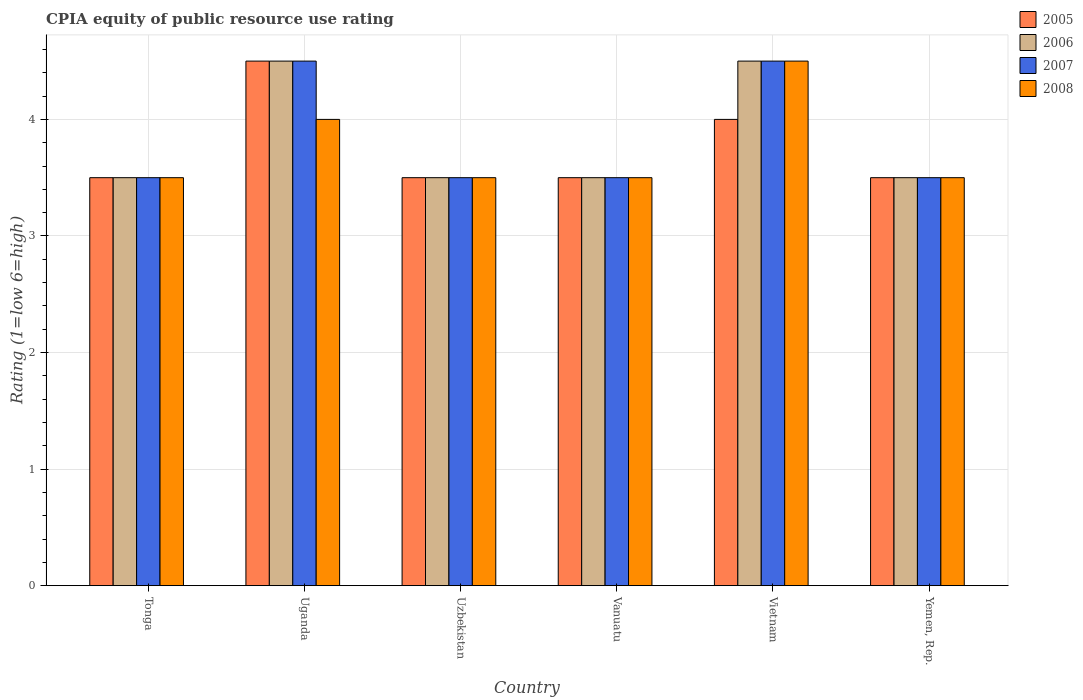Are the number of bars per tick equal to the number of legend labels?
Your answer should be very brief. Yes. Are the number of bars on each tick of the X-axis equal?
Make the answer very short. Yes. How many bars are there on the 4th tick from the right?
Make the answer very short. 4. What is the label of the 6th group of bars from the left?
Offer a very short reply. Yemen, Rep. What is the CPIA rating in 2008 in Uzbekistan?
Your answer should be compact. 3.5. Across all countries, what is the maximum CPIA rating in 2005?
Make the answer very short. 4.5. In which country was the CPIA rating in 2006 maximum?
Keep it short and to the point. Uganda. In which country was the CPIA rating in 2008 minimum?
Keep it short and to the point. Tonga. What is the average CPIA rating in 2007 per country?
Your answer should be very brief. 3.83. What is the difference between the CPIA rating of/in 2008 and CPIA rating of/in 2005 in Vanuatu?
Your response must be concise. 0. What is the ratio of the CPIA rating in 2008 in Uganda to that in Vanuatu?
Provide a succinct answer. 1.14. What is the difference between the highest and the second highest CPIA rating in 2005?
Ensure brevity in your answer.  -1. In how many countries, is the CPIA rating in 2005 greater than the average CPIA rating in 2005 taken over all countries?
Provide a short and direct response. 2. What does the 4th bar from the right in Uzbekistan represents?
Offer a terse response. 2005. Where does the legend appear in the graph?
Keep it short and to the point. Top right. What is the title of the graph?
Your answer should be compact. CPIA equity of public resource use rating. What is the label or title of the X-axis?
Provide a succinct answer. Country. What is the label or title of the Y-axis?
Offer a very short reply. Rating (1=low 6=high). What is the Rating (1=low 6=high) of 2005 in Tonga?
Your response must be concise. 3.5. What is the Rating (1=low 6=high) of 2006 in Tonga?
Provide a succinct answer. 3.5. What is the Rating (1=low 6=high) of 2007 in Tonga?
Offer a terse response. 3.5. What is the Rating (1=low 6=high) in 2008 in Tonga?
Provide a succinct answer. 3.5. What is the Rating (1=low 6=high) of 2005 in Uganda?
Ensure brevity in your answer.  4.5. What is the Rating (1=low 6=high) in 2006 in Uganda?
Your answer should be compact. 4.5. What is the Rating (1=low 6=high) in 2007 in Uganda?
Ensure brevity in your answer.  4.5. What is the Rating (1=low 6=high) in 2008 in Uganda?
Your answer should be compact. 4. What is the Rating (1=low 6=high) in 2006 in Uzbekistan?
Your response must be concise. 3.5. What is the Rating (1=low 6=high) of 2007 in Uzbekistan?
Offer a terse response. 3.5. What is the Rating (1=low 6=high) of 2008 in Uzbekistan?
Offer a terse response. 3.5. What is the Rating (1=low 6=high) of 2007 in Vanuatu?
Ensure brevity in your answer.  3.5. What is the Rating (1=low 6=high) in 2005 in Vietnam?
Make the answer very short. 4. What is the Rating (1=low 6=high) of 2006 in Vietnam?
Make the answer very short. 4.5. What is the Rating (1=low 6=high) in 2007 in Vietnam?
Provide a succinct answer. 4.5. What is the Rating (1=low 6=high) of 2007 in Yemen, Rep.?
Make the answer very short. 3.5. Across all countries, what is the maximum Rating (1=low 6=high) of 2005?
Ensure brevity in your answer.  4.5. Across all countries, what is the maximum Rating (1=low 6=high) of 2007?
Give a very brief answer. 4.5. Across all countries, what is the minimum Rating (1=low 6=high) of 2005?
Provide a short and direct response. 3.5. Across all countries, what is the minimum Rating (1=low 6=high) of 2006?
Offer a very short reply. 3.5. What is the total Rating (1=low 6=high) in 2005 in the graph?
Your response must be concise. 22.5. What is the total Rating (1=low 6=high) of 2007 in the graph?
Your answer should be compact. 23. What is the total Rating (1=low 6=high) of 2008 in the graph?
Ensure brevity in your answer.  22.5. What is the difference between the Rating (1=low 6=high) in 2006 in Tonga and that in Uganda?
Provide a short and direct response. -1. What is the difference between the Rating (1=low 6=high) of 2006 in Tonga and that in Uzbekistan?
Offer a terse response. 0. What is the difference between the Rating (1=low 6=high) of 2005 in Tonga and that in Vanuatu?
Offer a terse response. 0. What is the difference between the Rating (1=low 6=high) of 2006 in Tonga and that in Vanuatu?
Offer a very short reply. 0. What is the difference between the Rating (1=low 6=high) in 2007 in Tonga and that in Vanuatu?
Keep it short and to the point. 0. What is the difference between the Rating (1=low 6=high) of 2008 in Tonga and that in Vanuatu?
Provide a succinct answer. 0. What is the difference between the Rating (1=low 6=high) in 2005 in Tonga and that in Vietnam?
Your response must be concise. -0.5. What is the difference between the Rating (1=low 6=high) of 2008 in Tonga and that in Vietnam?
Provide a short and direct response. -1. What is the difference between the Rating (1=low 6=high) in 2005 in Tonga and that in Yemen, Rep.?
Give a very brief answer. 0. What is the difference between the Rating (1=low 6=high) of 2006 in Tonga and that in Yemen, Rep.?
Your answer should be compact. 0. What is the difference between the Rating (1=low 6=high) in 2005 in Uganda and that in Uzbekistan?
Provide a short and direct response. 1. What is the difference between the Rating (1=low 6=high) of 2006 in Uganda and that in Uzbekistan?
Provide a succinct answer. 1. What is the difference between the Rating (1=low 6=high) in 2007 in Uganda and that in Vanuatu?
Your answer should be very brief. 1. What is the difference between the Rating (1=low 6=high) in 2005 in Uganda and that in Vietnam?
Offer a very short reply. 0.5. What is the difference between the Rating (1=low 6=high) in 2006 in Uganda and that in Vietnam?
Your response must be concise. 0. What is the difference between the Rating (1=low 6=high) in 2007 in Uganda and that in Vietnam?
Provide a succinct answer. 0. What is the difference between the Rating (1=low 6=high) in 2008 in Uganda and that in Vietnam?
Offer a very short reply. -0.5. What is the difference between the Rating (1=low 6=high) in 2006 in Uganda and that in Yemen, Rep.?
Keep it short and to the point. 1. What is the difference between the Rating (1=low 6=high) of 2006 in Uzbekistan and that in Vanuatu?
Your answer should be very brief. 0. What is the difference between the Rating (1=low 6=high) of 2007 in Uzbekistan and that in Vanuatu?
Give a very brief answer. 0. What is the difference between the Rating (1=low 6=high) of 2005 in Uzbekistan and that in Vietnam?
Ensure brevity in your answer.  -0.5. What is the difference between the Rating (1=low 6=high) of 2007 in Uzbekistan and that in Vietnam?
Your answer should be very brief. -1. What is the difference between the Rating (1=low 6=high) of 2008 in Uzbekistan and that in Yemen, Rep.?
Give a very brief answer. 0. What is the difference between the Rating (1=low 6=high) of 2005 in Vanuatu and that in Vietnam?
Offer a very short reply. -0.5. What is the difference between the Rating (1=low 6=high) in 2007 in Vanuatu and that in Vietnam?
Your answer should be very brief. -1. What is the difference between the Rating (1=low 6=high) of 2008 in Vanuatu and that in Vietnam?
Make the answer very short. -1. What is the difference between the Rating (1=low 6=high) of 2005 in Vanuatu and that in Yemen, Rep.?
Make the answer very short. 0. What is the difference between the Rating (1=low 6=high) in 2007 in Vanuatu and that in Yemen, Rep.?
Give a very brief answer. 0. What is the difference between the Rating (1=low 6=high) in 2008 in Vanuatu and that in Yemen, Rep.?
Your answer should be compact. 0. What is the difference between the Rating (1=low 6=high) in 2005 in Vietnam and that in Yemen, Rep.?
Offer a terse response. 0.5. What is the difference between the Rating (1=low 6=high) of 2006 in Vietnam and that in Yemen, Rep.?
Provide a short and direct response. 1. What is the difference between the Rating (1=low 6=high) in 2005 in Tonga and the Rating (1=low 6=high) in 2007 in Uganda?
Your response must be concise. -1. What is the difference between the Rating (1=low 6=high) of 2006 in Tonga and the Rating (1=low 6=high) of 2007 in Uganda?
Ensure brevity in your answer.  -1. What is the difference between the Rating (1=low 6=high) in 2007 in Tonga and the Rating (1=low 6=high) in 2008 in Uganda?
Offer a terse response. -0.5. What is the difference between the Rating (1=low 6=high) of 2005 in Tonga and the Rating (1=low 6=high) of 2006 in Uzbekistan?
Offer a very short reply. 0. What is the difference between the Rating (1=low 6=high) in 2005 in Tonga and the Rating (1=low 6=high) in 2008 in Uzbekistan?
Your answer should be compact. 0. What is the difference between the Rating (1=low 6=high) in 2006 in Tonga and the Rating (1=low 6=high) in 2007 in Uzbekistan?
Ensure brevity in your answer.  0. What is the difference between the Rating (1=low 6=high) in 2006 in Tonga and the Rating (1=low 6=high) in 2008 in Uzbekistan?
Offer a very short reply. 0. What is the difference between the Rating (1=low 6=high) of 2005 in Tonga and the Rating (1=low 6=high) of 2007 in Vanuatu?
Offer a terse response. 0. What is the difference between the Rating (1=low 6=high) of 2005 in Tonga and the Rating (1=low 6=high) of 2008 in Vanuatu?
Make the answer very short. 0. What is the difference between the Rating (1=low 6=high) in 2006 in Tonga and the Rating (1=low 6=high) in 2007 in Vanuatu?
Your response must be concise. 0. What is the difference between the Rating (1=low 6=high) in 2007 in Tonga and the Rating (1=low 6=high) in 2008 in Vanuatu?
Give a very brief answer. 0. What is the difference between the Rating (1=low 6=high) of 2005 in Tonga and the Rating (1=low 6=high) of 2006 in Vietnam?
Provide a short and direct response. -1. What is the difference between the Rating (1=low 6=high) in 2005 in Tonga and the Rating (1=low 6=high) in 2008 in Vietnam?
Make the answer very short. -1. What is the difference between the Rating (1=low 6=high) in 2006 in Tonga and the Rating (1=low 6=high) in 2008 in Vietnam?
Offer a terse response. -1. What is the difference between the Rating (1=low 6=high) of 2007 in Tonga and the Rating (1=low 6=high) of 2008 in Vietnam?
Your answer should be very brief. -1. What is the difference between the Rating (1=low 6=high) in 2005 in Tonga and the Rating (1=low 6=high) in 2006 in Yemen, Rep.?
Provide a short and direct response. 0. What is the difference between the Rating (1=low 6=high) in 2005 in Tonga and the Rating (1=low 6=high) in 2007 in Yemen, Rep.?
Offer a very short reply. 0. What is the difference between the Rating (1=low 6=high) of 2005 in Tonga and the Rating (1=low 6=high) of 2008 in Yemen, Rep.?
Offer a very short reply. 0. What is the difference between the Rating (1=low 6=high) of 2006 in Tonga and the Rating (1=low 6=high) of 2008 in Yemen, Rep.?
Your response must be concise. 0. What is the difference between the Rating (1=low 6=high) in 2005 in Uganda and the Rating (1=low 6=high) in 2007 in Uzbekistan?
Make the answer very short. 1. What is the difference between the Rating (1=low 6=high) in 2005 in Uganda and the Rating (1=low 6=high) in 2008 in Uzbekistan?
Your answer should be compact. 1. What is the difference between the Rating (1=low 6=high) of 2006 in Uganda and the Rating (1=low 6=high) of 2008 in Uzbekistan?
Offer a terse response. 1. What is the difference between the Rating (1=low 6=high) of 2005 in Uganda and the Rating (1=low 6=high) of 2006 in Vanuatu?
Make the answer very short. 1. What is the difference between the Rating (1=low 6=high) of 2006 in Uganda and the Rating (1=low 6=high) of 2008 in Vanuatu?
Your response must be concise. 1. What is the difference between the Rating (1=low 6=high) of 2007 in Uganda and the Rating (1=low 6=high) of 2008 in Vanuatu?
Provide a short and direct response. 1. What is the difference between the Rating (1=low 6=high) of 2005 in Uganda and the Rating (1=low 6=high) of 2006 in Vietnam?
Give a very brief answer. 0. What is the difference between the Rating (1=low 6=high) of 2005 in Uganda and the Rating (1=low 6=high) of 2007 in Vietnam?
Your answer should be compact. 0. What is the difference between the Rating (1=low 6=high) in 2005 in Uganda and the Rating (1=low 6=high) in 2008 in Vietnam?
Offer a very short reply. 0. What is the difference between the Rating (1=low 6=high) in 2007 in Uganda and the Rating (1=low 6=high) in 2008 in Vietnam?
Your answer should be very brief. 0. What is the difference between the Rating (1=low 6=high) of 2005 in Uganda and the Rating (1=low 6=high) of 2006 in Yemen, Rep.?
Offer a very short reply. 1. What is the difference between the Rating (1=low 6=high) in 2005 in Uganda and the Rating (1=low 6=high) in 2008 in Yemen, Rep.?
Keep it short and to the point. 1. What is the difference between the Rating (1=low 6=high) in 2007 in Uganda and the Rating (1=low 6=high) in 2008 in Yemen, Rep.?
Keep it short and to the point. 1. What is the difference between the Rating (1=low 6=high) in 2005 in Uzbekistan and the Rating (1=low 6=high) in 2008 in Vanuatu?
Your answer should be compact. 0. What is the difference between the Rating (1=low 6=high) of 2006 in Uzbekistan and the Rating (1=low 6=high) of 2007 in Vietnam?
Make the answer very short. -1. What is the difference between the Rating (1=low 6=high) in 2007 in Uzbekistan and the Rating (1=low 6=high) in 2008 in Vietnam?
Ensure brevity in your answer.  -1. What is the difference between the Rating (1=low 6=high) in 2005 in Uzbekistan and the Rating (1=low 6=high) in 2006 in Yemen, Rep.?
Provide a succinct answer. 0. What is the difference between the Rating (1=low 6=high) of 2005 in Uzbekistan and the Rating (1=low 6=high) of 2007 in Yemen, Rep.?
Provide a succinct answer. 0. What is the difference between the Rating (1=low 6=high) of 2006 in Uzbekistan and the Rating (1=low 6=high) of 2007 in Yemen, Rep.?
Keep it short and to the point. 0. What is the difference between the Rating (1=low 6=high) in 2005 in Vanuatu and the Rating (1=low 6=high) in 2007 in Vietnam?
Your answer should be very brief. -1. What is the difference between the Rating (1=low 6=high) of 2005 in Vanuatu and the Rating (1=low 6=high) of 2008 in Vietnam?
Provide a short and direct response. -1. What is the difference between the Rating (1=low 6=high) in 2007 in Vanuatu and the Rating (1=low 6=high) in 2008 in Vietnam?
Ensure brevity in your answer.  -1. What is the difference between the Rating (1=low 6=high) in 2006 in Vanuatu and the Rating (1=low 6=high) in 2008 in Yemen, Rep.?
Make the answer very short. 0. What is the difference between the Rating (1=low 6=high) in 2005 in Vietnam and the Rating (1=low 6=high) in 2007 in Yemen, Rep.?
Keep it short and to the point. 0.5. What is the difference between the Rating (1=low 6=high) in 2006 in Vietnam and the Rating (1=low 6=high) in 2007 in Yemen, Rep.?
Offer a terse response. 1. What is the average Rating (1=low 6=high) of 2005 per country?
Give a very brief answer. 3.75. What is the average Rating (1=low 6=high) in 2006 per country?
Ensure brevity in your answer.  3.83. What is the average Rating (1=low 6=high) in 2007 per country?
Provide a succinct answer. 3.83. What is the average Rating (1=low 6=high) of 2008 per country?
Your answer should be very brief. 3.75. What is the difference between the Rating (1=low 6=high) of 2005 and Rating (1=low 6=high) of 2006 in Tonga?
Provide a short and direct response. 0. What is the difference between the Rating (1=low 6=high) in 2005 and Rating (1=low 6=high) in 2008 in Tonga?
Your answer should be very brief. 0. What is the difference between the Rating (1=low 6=high) in 2006 and Rating (1=low 6=high) in 2007 in Tonga?
Keep it short and to the point. 0. What is the difference between the Rating (1=low 6=high) of 2005 and Rating (1=low 6=high) of 2007 in Uganda?
Your response must be concise. 0. What is the difference between the Rating (1=low 6=high) of 2006 and Rating (1=low 6=high) of 2008 in Uganda?
Offer a terse response. 0.5. What is the difference between the Rating (1=low 6=high) in 2005 and Rating (1=low 6=high) in 2008 in Uzbekistan?
Offer a very short reply. 0. What is the difference between the Rating (1=low 6=high) in 2006 and Rating (1=low 6=high) in 2008 in Uzbekistan?
Ensure brevity in your answer.  0. What is the difference between the Rating (1=low 6=high) in 2007 and Rating (1=low 6=high) in 2008 in Uzbekistan?
Give a very brief answer. 0. What is the difference between the Rating (1=low 6=high) in 2005 and Rating (1=low 6=high) in 2006 in Vanuatu?
Offer a terse response. 0. What is the difference between the Rating (1=low 6=high) of 2006 and Rating (1=low 6=high) of 2007 in Vanuatu?
Offer a terse response. 0. What is the difference between the Rating (1=low 6=high) of 2006 and Rating (1=low 6=high) of 2008 in Vanuatu?
Provide a succinct answer. 0. What is the difference between the Rating (1=low 6=high) of 2005 and Rating (1=low 6=high) of 2006 in Vietnam?
Provide a short and direct response. -0.5. What is the difference between the Rating (1=low 6=high) of 2005 and Rating (1=low 6=high) of 2007 in Vietnam?
Provide a short and direct response. -0.5. What is the difference between the Rating (1=low 6=high) in 2006 and Rating (1=low 6=high) in 2007 in Vietnam?
Give a very brief answer. 0. What is the difference between the Rating (1=low 6=high) in 2006 and Rating (1=low 6=high) in 2008 in Vietnam?
Your answer should be compact. 0. What is the difference between the Rating (1=low 6=high) of 2006 and Rating (1=low 6=high) of 2008 in Yemen, Rep.?
Ensure brevity in your answer.  0. What is the ratio of the Rating (1=low 6=high) of 2006 in Tonga to that in Uganda?
Your answer should be compact. 0.78. What is the ratio of the Rating (1=low 6=high) in 2006 in Tonga to that in Uzbekistan?
Ensure brevity in your answer.  1. What is the ratio of the Rating (1=low 6=high) in 2008 in Tonga to that in Uzbekistan?
Provide a short and direct response. 1. What is the ratio of the Rating (1=low 6=high) in 2005 in Tonga to that in Vanuatu?
Make the answer very short. 1. What is the ratio of the Rating (1=low 6=high) in 2008 in Tonga to that in Vietnam?
Offer a terse response. 0.78. What is the ratio of the Rating (1=low 6=high) of 2005 in Tonga to that in Yemen, Rep.?
Your response must be concise. 1. What is the ratio of the Rating (1=low 6=high) in 2007 in Tonga to that in Yemen, Rep.?
Provide a short and direct response. 1. What is the ratio of the Rating (1=low 6=high) in 2008 in Tonga to that in Yemen, Rep.?
Make the answer very short. 1. What is the ratio of the Rating (1=low 6=high) in 2008 in Uganda to that in Uzbekistan?
Provide a succinct answer. 1.14. What is the ratio of the Rating (1=low 6=high) of 2005 in Uganda to that in Vanuatu?
Your response must be concise. 1.29. What is the ratio of the Rating (1=low 6=high) of 2007 in Uganda to that in Vanuatu?
Provide a succinct answer. 1.29. What is the ratio of the Rating (1=low 6=high) of 2005 in Uganda to that in Yemen, Rep.?
Your answer should be compact. 1.29. What is the ratio of the Rating (1=low 6=high) of 2007 in Uganda to that in Yemen, Rep.?
Offer a terse response. 1.29. What is the ratio of the Rating (1=low 6=high) in 2008 in Uganda to that in Yemen, Rep.?
Your answer should be compact. 1.14. What is the ratio of the Rating (1=low 6=high) of 2006 in Uzbekistan to that in Vanuatu?
Ensure brevity in your answer.  1. What is the ratio of the Rating (1=low 6=high) in 2008 in Uzbekistan to that in Vanuatu?
Make the answer very short. 1. What is the ratio of the Rating (1=low 6=high) in 2006 in Uzbekistan to that in Vietnam?
Keep it short and to the point. 0.78. What is the ratio of the Rating (1=low 6=high) of 2007 in Uzbekistan to that in Vietnam?
Provide a succinct answer. 0.78. What is the ratio of the Rating (1=low 6=high) of 2008 in Uzbekistan to that in Vietnam?
Your answer should be very brief. 0.78. What is the ratio of the Rating (1=low 6=high) in 2005 in Uzbekistan to that in Yemen, Rep.?
Offer a very short reply. 1. What is the ratio of the Rating (1=low 6=high) of 2006 in Uzbekistan to that in Yemen, Rep.?
Your response must be concise. 1. What is the ratio of the Rating (1=low 6=high) of 2007 in Uzbekistan to that in Yemen, Rep.?
Your answer should be very brief. 1. What is the ratio of the Rating (1=low 6=high) of 2008 in Uzbekistan to that in Yemen, Rep.?
Your response must be concise. 1. What is the ratio of the Rating (1=low 6=high) of 2006 in Vanuatu to that in Vietnam?
Make the answer very short. 0.78. What is the ratio of the Rating (1=low 6=high) of 2007 in Vanuatu to that in Vietnam?
Provide a succinct answer. 0.78. What is the ratio of the Rating (1=low 6=high) in 2008 in Vanuatu to that in Vietnam?
Give a very brief answer. 0.78. What is the ratio of the Rating (1=low 6=high) of 2005 in Vanuatu to that in Yemen, Rep.?
Offer a terse response. 1. What is the ratio of the Rating (1=low 6=high) in 2006 in Vanuatu to that in Yemen, Rep.?
Provide a short and direct response. 1. What is the ratio of the Rating (1=low 6=high) in 2007 in Vanuatu to that in Yemen, Rep.?
Ensure brevity in your answer.  1. What is the ratio of the Rating (1=low 6=high) of 2007 in Vietnam to that in Yemen, Rep.?
Ensure brevity in your answer.  1.29. What is the difference between the highest and the second highest Rating (1=low 6=high) of 2007?
Make the answer very short. 0. What is the difference between the highest and the second highest Rating (1=low 6=high) in 2008?
Offer a terse response. 0.5. What is the difference between the highest and the lowest Rating (1=low 6=high) in 2005?
Provide a short and direct response. 1. What is the difference between the highest and the lowest Rating (1=low 6=high) in 2007?
Provide a succinct answer. 1. 